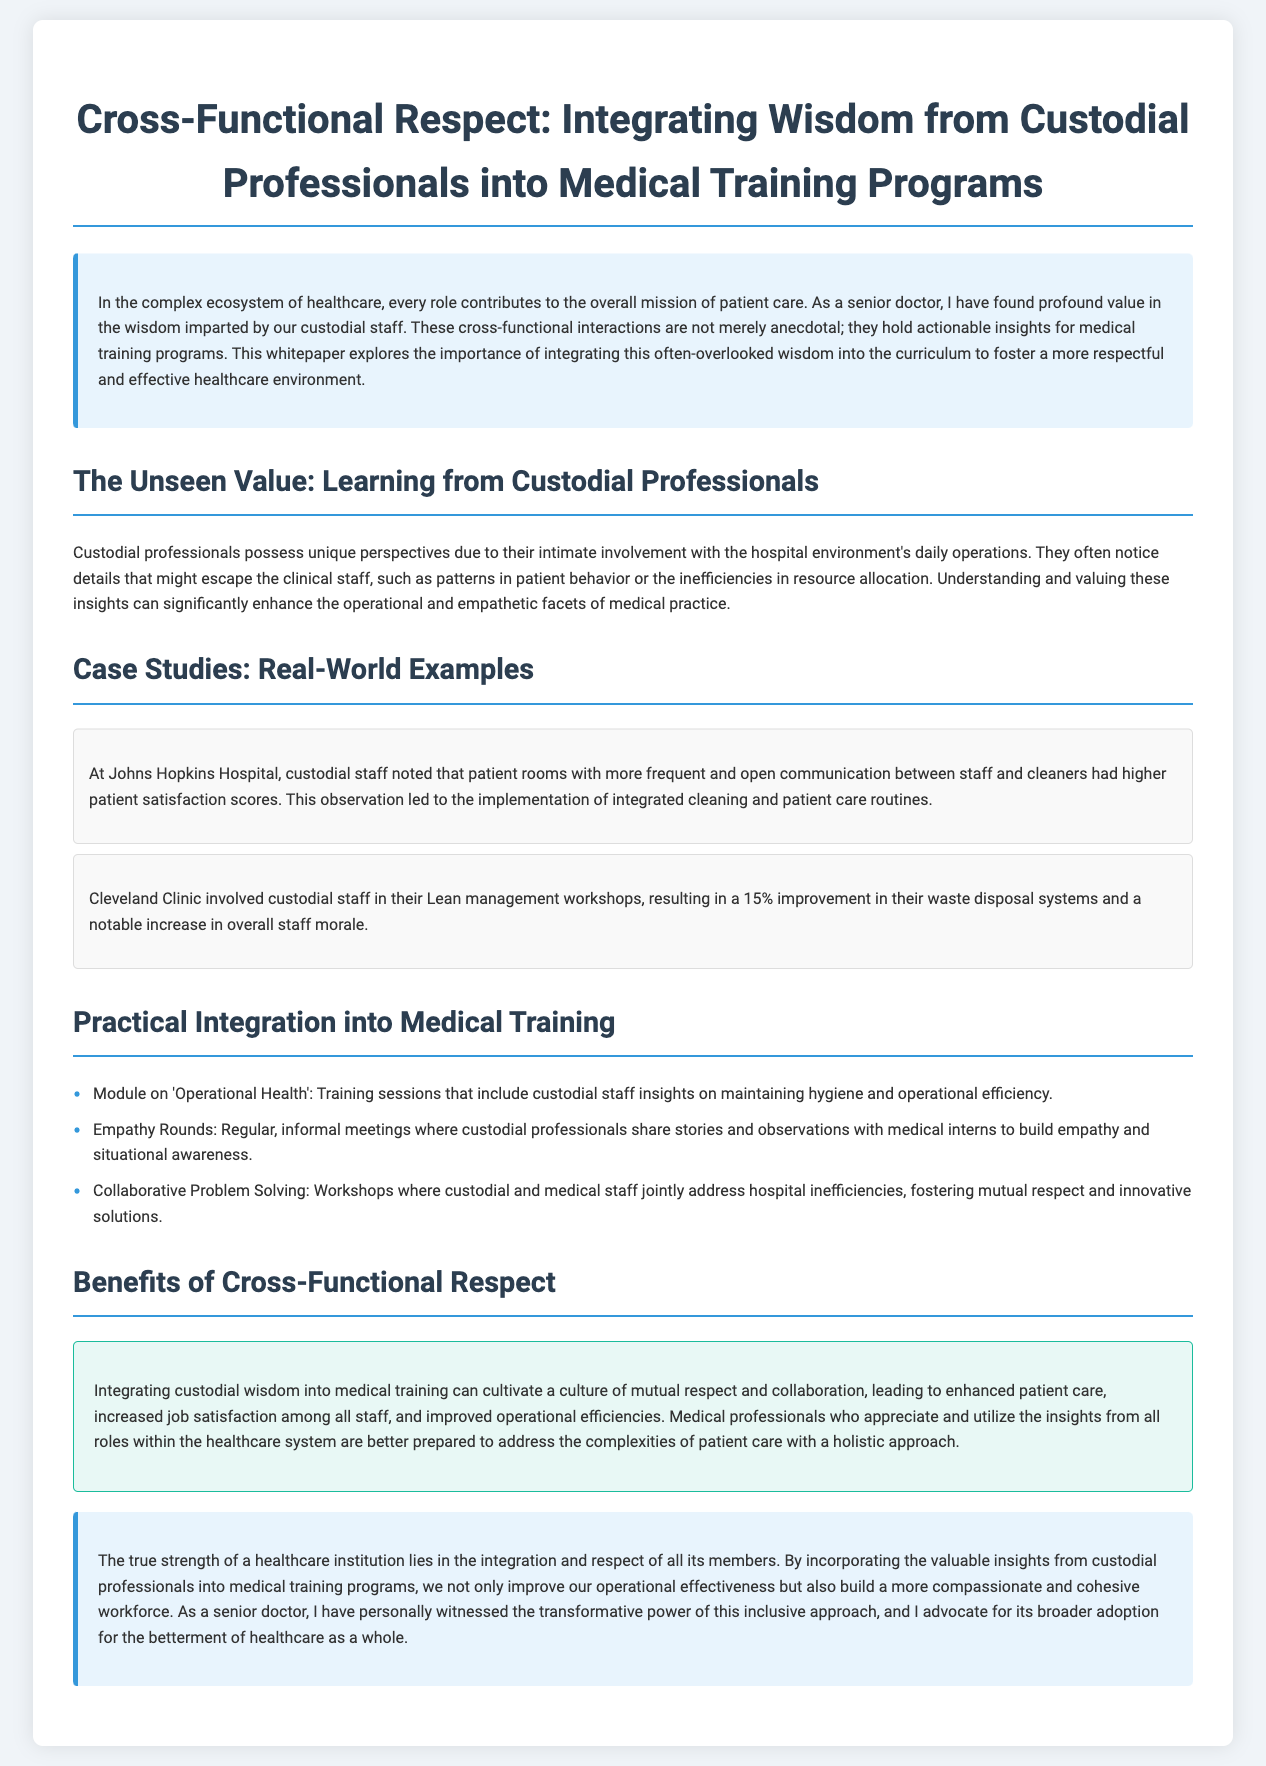What is the title of the whitepaper? The title is mentioned at the beginning of the document.
Answer: Cross-Functional Respect: Integrating Wisdom from Custodial Professionals into Medical Training Programs What benefit does integrating custodial wisdom into medical training provide? The document states various benefits of this integration.
Answer: Cultivate a culture of mutual respect and collaboration At which hospital was a notable case study conducted? The case studies mention specific hospitals.
Answer: Johns Hopkins Hospital What percentage improvement did Cleveland Clinic achieve in their waste disposal systems? The case study provided a specific improvement percentage.
Answer: 15% What type of training module is suggested in the document? The document lists specific modules to be integrated into training.
Answer: Operational Health What is the purpose of Empathy Rounds? The document describes the role and aim of Empathy Rounds.
Answer: To build empathy and situational awareness Which workshop type fosters mutual respect between custodial and medical staff? The document mentions a specific activity designed for collaboration.
Answer: Collaborative Problem Solving Which sentiment do custodial professionals help build according to the conclusion? The conclusion emphasizes the outcome of integrating custodial insights.
Answer: Compassionate and cohesive workforce 